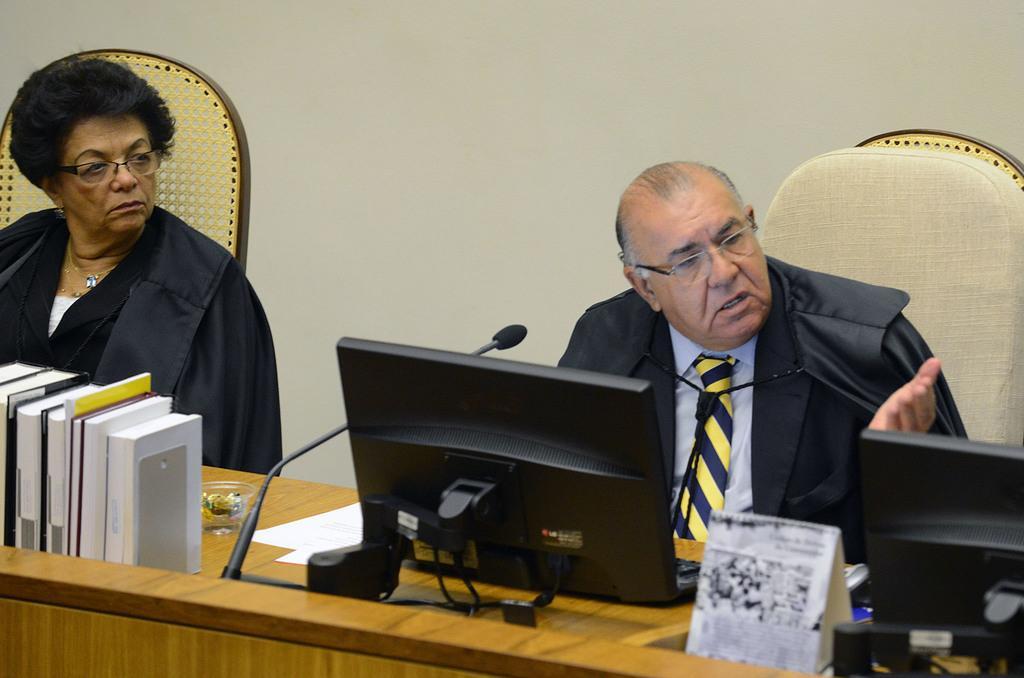Please provide a concise description of this image. In this image I can see two persons are sitting on chairs. I can see both of them are wearing black colour coat. Here I can see a table and on it I can see few books, few monitors, a mic, few white colour papers and few other stuffs. 